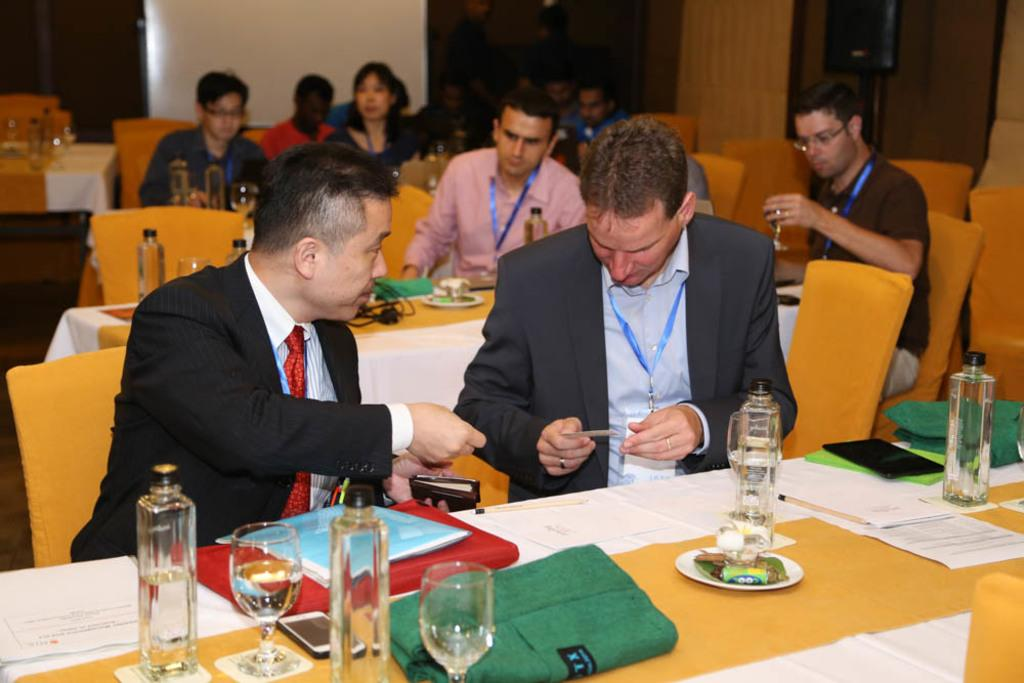What are the people in the image doing? The people in the image are sitting. What objects are on the tables in the image? Plates, jars, and glasses are visible on the tables in the image. What type of furniture is present in the image? Chairs are present in the image. What can be seen on the wall in the image? The wall is visible in the image. What is the credit score of the person sitting at the table in the image? There is no information about the credit score of the person sitting at the table in the image. 